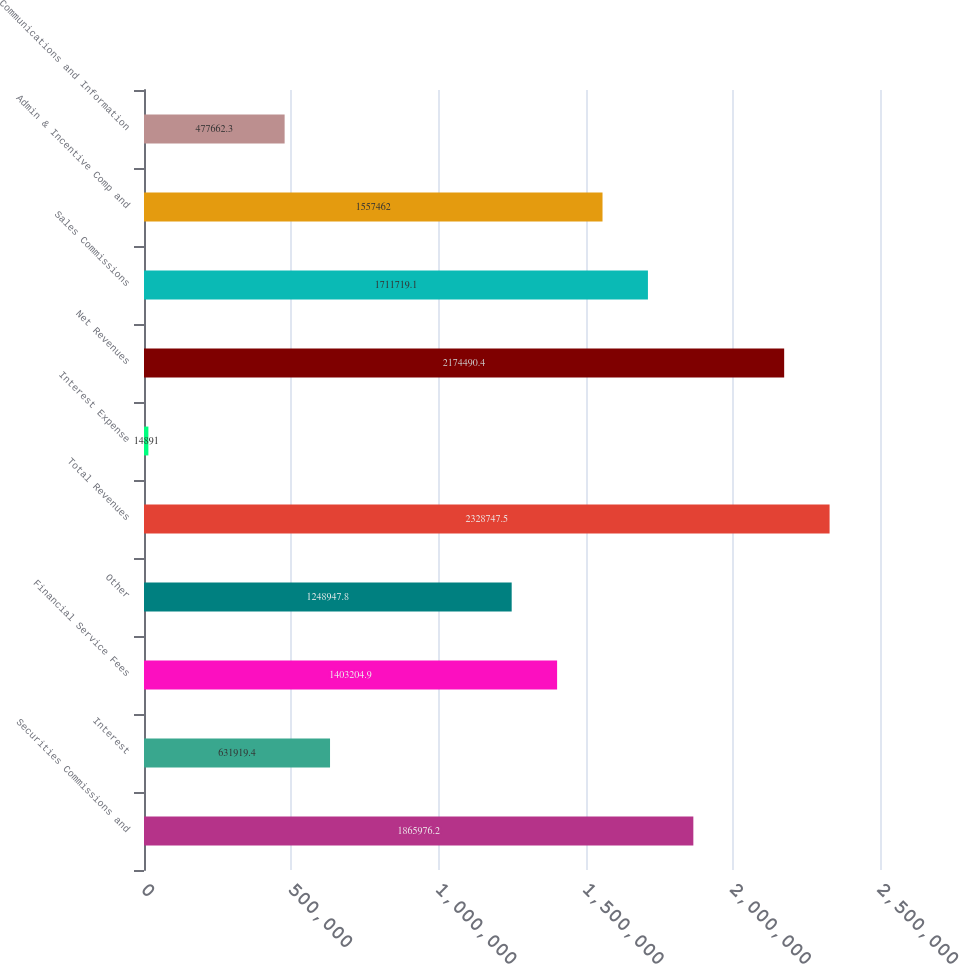Convert chart. <chart><loc_0><loc_0><loc_500><loc_500><bar_chart><fcel>Securities Commissions and<fcel>Interest<fcel>Financial Service Fees<fcel>Other<fcel>Total Revenues<fcel>Interest Expense<fcel>Net Revenues<fcel>Sales Commissions<fcel>Admin & Incentive Comp and<fcel>Communications and Information<nl><fcel>1.86598e+06<fcel>631919<fcel>1.4032e+06<fcel>1.24895e+06<fcel>2.32875e+06<fcel>14891<fcel>2.17449e+06<fcel>1.71172e+06<fcel>1.55746e+06<fcel>477662<nl></chart> 